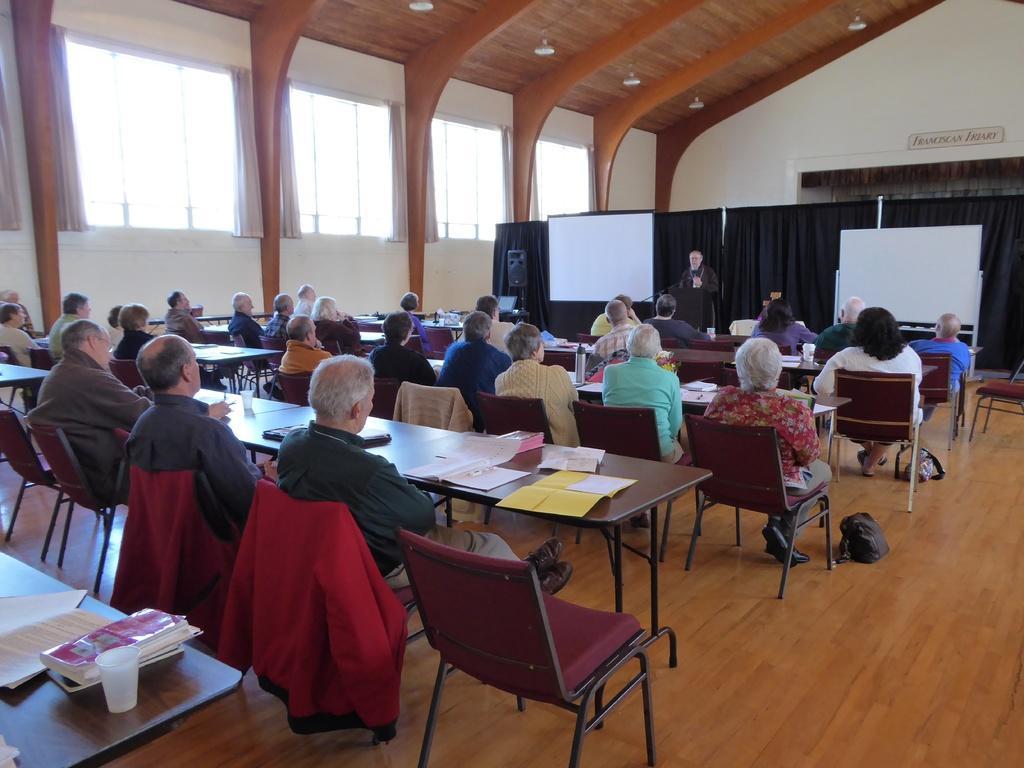Could you give a brief overview of what you see in this image? In this image there is a man he wear black dress. On the left there is a table on that there is a paper and book. On the left there are many people sitting on the chairs and staring at the screen. 